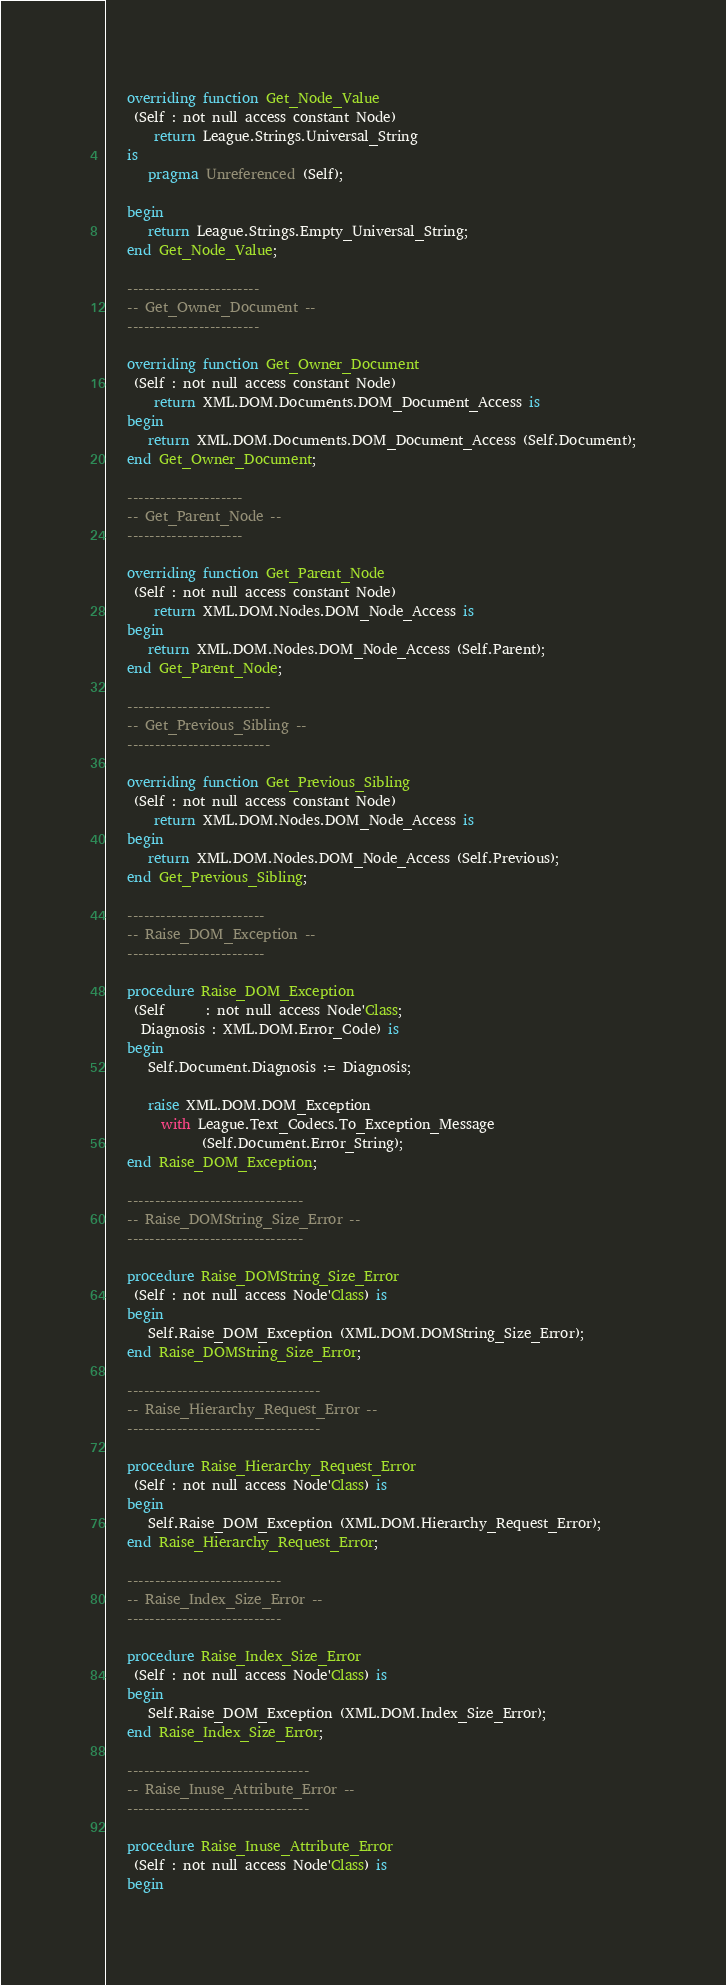Convert code to text. <code><loc_0><loc_0><loc_500><loc_500><_Ada_>   overriding function Get_Node_Value
    (Self : not null access constant Node)
       return League.Strings.Universal_String
   is
      pragma Unreferenced (Self);

   begin
      return League.Strings.Empty_Universal_String;
   end Get_Node_Value;

   ------------------------
   -- Get_Owner_Document --
   ------------------------

   overriding function Get_Owner_Document
    (Self : not null access constant Node)
       return XML.DOM.Documents.DOM_Document_Access is
   begin
      return XML.DOM.Documents.DOM_Document_Access (Self.Document);
   end Get_Owner_Document;

   ---------------------
   -- Get_Parent_Node --
   ---------------------

   overriding function Get_Parent_Node
    (Self : not null access constant Node)
       return XML.DOM.Nodes.DOM_Node_Access is
   begin
      return XML.DOM.Nodes.DOM_Node_Access (Self.Parent);
   end Get_Parent_Node;

   --------------------------
   -- Get_Previous_Sibling --
   --------------------------

   overriding function Get_Previous_Sibling
    (Self : not null access constant Node)
       return XML.DOM.Nodes.DOM_Node_Access is
   begin
      return XML.DOM.Nodes.DOM_Node_Access (Self.Previous);
   end Get_Previous_Sibling;

   -------------------------
   -- Raise_DOM_Exception --
   -------------------------

   procedure Raise_DOM_Exception
    (Self      : not null access Node'Class;
     Diagnosis : XML.DOM.Error_Code) is
   begin
      Self.Document.Diagnosis := Diagnosis;

      raise XML.DOM.DOM_Exception
        with League.Text_Codecs.To_Exception_Message
              (Self.Document.Error_String);
   end Raise_DOM_Exception;

   --------------------------------
   -- Raise_DOMString_Size_Error --
   --------------------------------

   procedure Raise_DOMString_Size_Error
    (Self : not null access Node'Class) is
   begin
      Self.Raise_DOM_Exception (XML.DOM.DOMString_Size_Error);
   end Raise_DOMString_Size_Error;

   -----------------------------------
   -- Raise_Hierarchy_Request_Error --
   -----------------------------------

   procedure Raise_Hierarchy_Request_Error
    (Self : not null access Node'Class) is
   begin
      Self.Raise_DOM_Exception (XML.DOM.Hierarchy_Request_Error);
   end Raise_Hierarchy_Request_Error;

   ----------------------------
   -- Raise_Index_Size_Error --
   ----------------------------

   procedure Raise_Index_Size_Error
    (Self : not null access Node'Class) is
   begin
      Self.Raise_DOM_Exception (XML.DOM.Index_Size_Error);
   end Raise_Index_Size_Error;

   ---------------------------------
   -- Raise_Inuse_Attribute_Error --
   ---------------------------------

   procedure Raise_Inuse_Attribute_Error
    (Self : not null access Node'Class) is
   begin</code> 